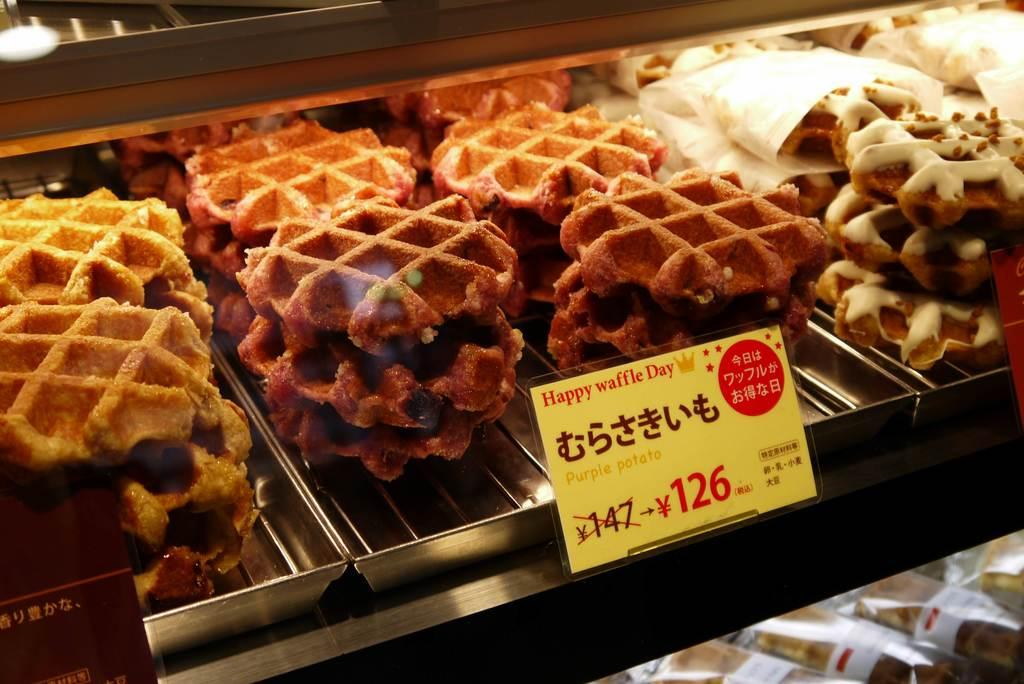What type of containers are holding the food items in the image? The food items are on steel trays in the image. What is the color of the board visible in the image? There is a yellow color board in the image. What can be found on the yellow color board? Something is written on the yellow color board. How are the food items colored in the image? The food items are in brown and white colors. How many dolls are sitting on the food items in the image? There are no dolls present in the image; it only features food items on steel trays and a yellow color board. Can you see any insects crawling on the food items in the image? There is no indication of insects on the food items in the image. 